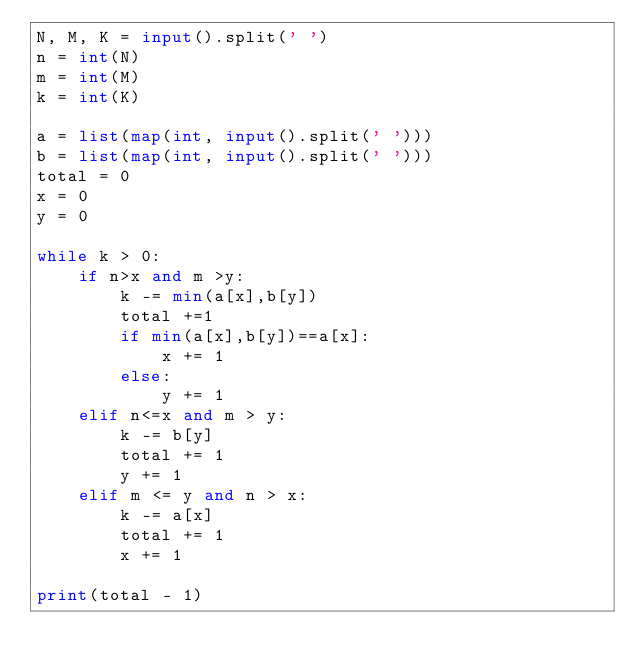Convert code to text. <code><loc_0><loc_0><loc_500><loc_500><_Python_>N, M, K = input().split(' ')
n = int(N)
m = int(M)
k = int(K)

a = list(map(int, input().split(' ')))
b = list(map(int, input().split(' ')))
total = 0
x = 0
y = 0

while k > 0:
    if n>x and m >y:
        k -= min(a[x],b[y])
        total +=1
        if min(a[x],b[y])==a[x]:
            x += 1
        else:
            y += 1
    elif n<=x and m > y:
        k -= b[y]
        total += 1
        y += 1
    elif m <= y and n > x:
        k -= a[x]
        total += 1
        x += 1
        
print(total - 1)</code> 